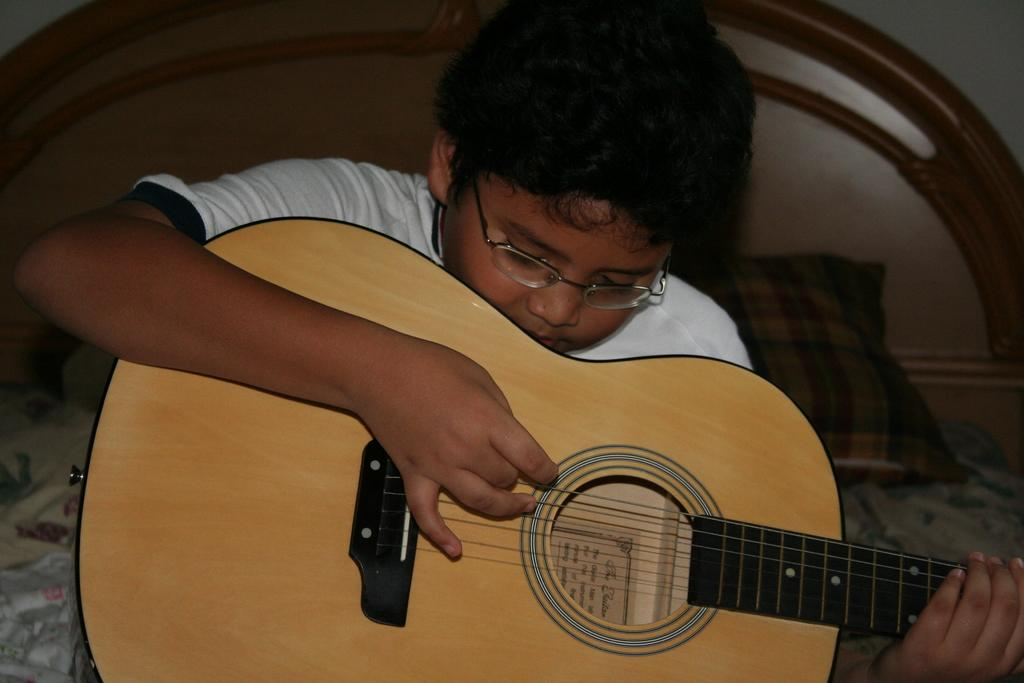Who is the main subject in the image? There is a boy in the image. What is the boy holding in the image? The boy is holding a guitar. What is the boy doing with the guitar? The boy is playing the guitar. Can you describe the boy's appearance in the image? The boy is wearing spectacles. What type of glue is the boy using to attach the bead to the guitar in the image? There is no glue or bead present in the image; the boy is simply playing the guitar. 